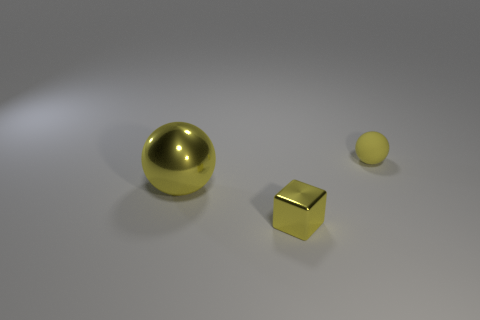There is a tiny thing that is on the right side of the small object that is in front of the big yellow metal object; what color is it?
Give a very brief answer. Yellow. There is a metal cube that is the same size as the yellow matte ball; what color is it?
Offer a terse response. Yellow. How many big objects are either green blocks or balls?
Your answer should be compact. 1. Are there more objects that are in front of the matte ball than large spheres that are behind the metallic block?
Your answer should be very brief. Yes. The rubber ball that is the same color as the big thing is what size?
Keep it short and to the point. Small. What number of other objects are there of the same size as the cube?
Provide a short and direct response. 1. Is the material of the yellow object that is to the right of the tiny yellow metal thing the same as the cube?
Give a very brief answer. No. What number of other things are there of the same color as the metallic ball?
Offer a terse response. 2. What number of other objects are there of the same shape as the tiny rubber object?
Keep it short and to the point. 1. There is a small yellow object left of the small yellow rubber object; is it the same shape as the yellow object that is on the right side of the small shiny cube?
Your answer should be very brief. No. 